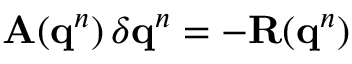<formula> <loc_0><loc_0><loc_500><loc_500>A ( q ^ { n } ) \, \delta q ^ { n } = - R ( q ^ { n } )</formula> 